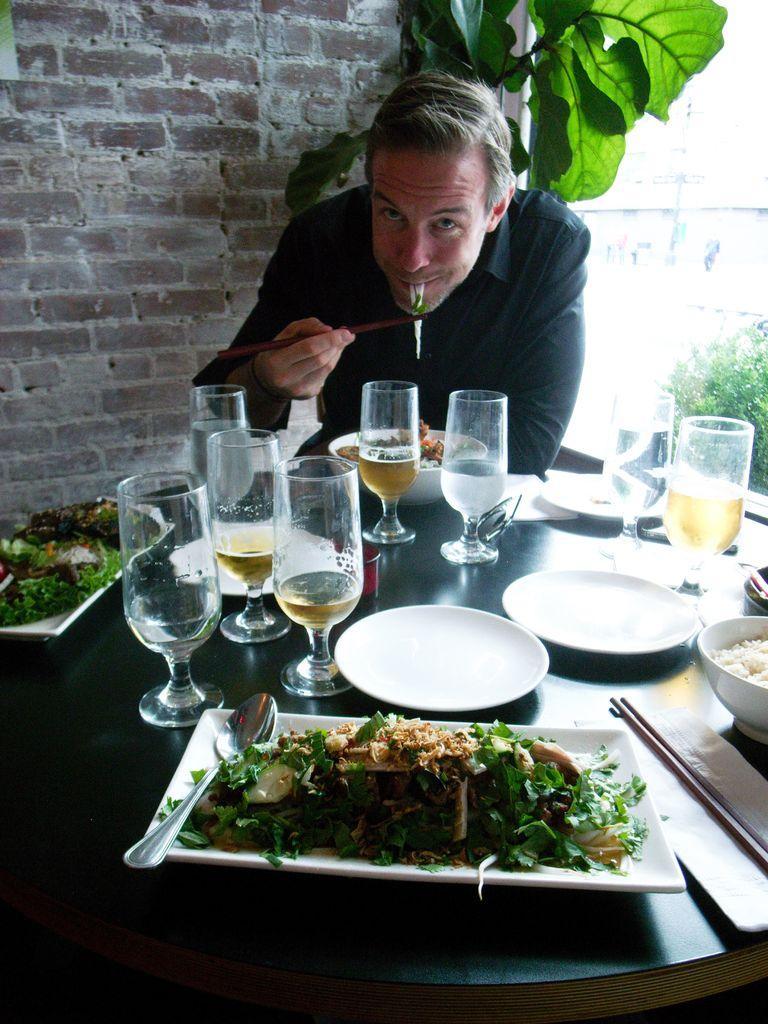Please provide a concise description of this image. In this picture a man is seated on the chair, and he is eating, in front of him can find couple of glasses, plates, spoons, bowls and some food on the table, in the background we can see couple of plants and a wall. 